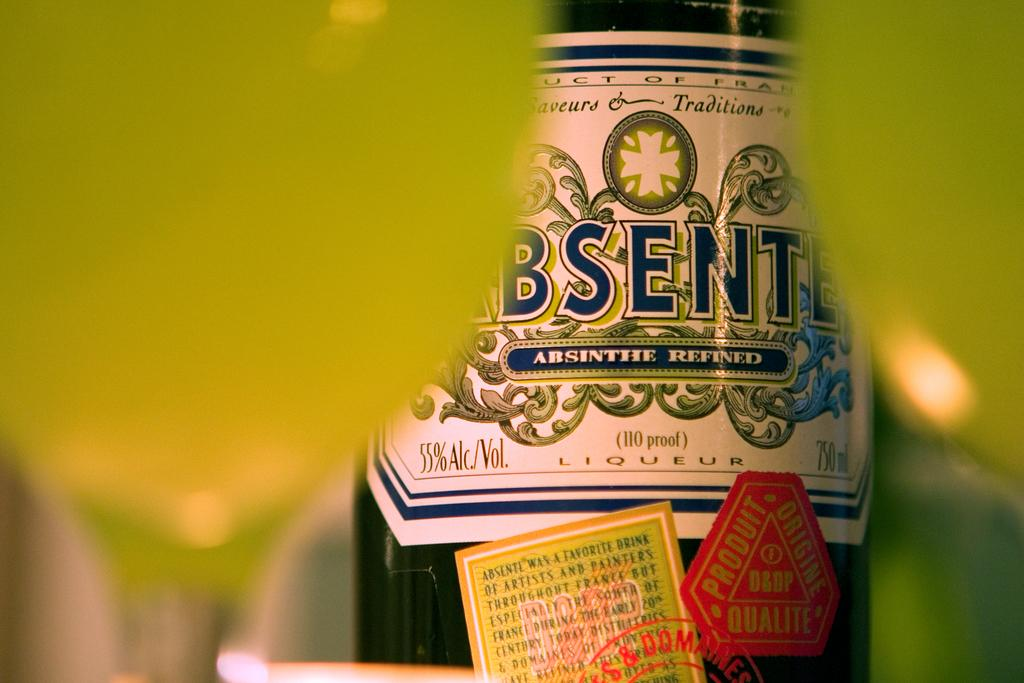Provide a one-sentence caption for the provided image. A bottle of absinthe is fifty five percent alcohol. 